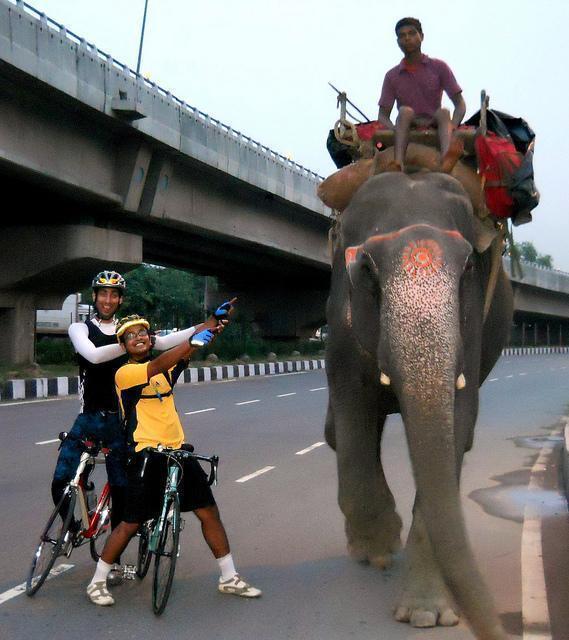What are the helmets shells made from?
Choose the right answer from the provided options to respond to the question.
Options: Plastic, steel, foam, clay. Plastic. 